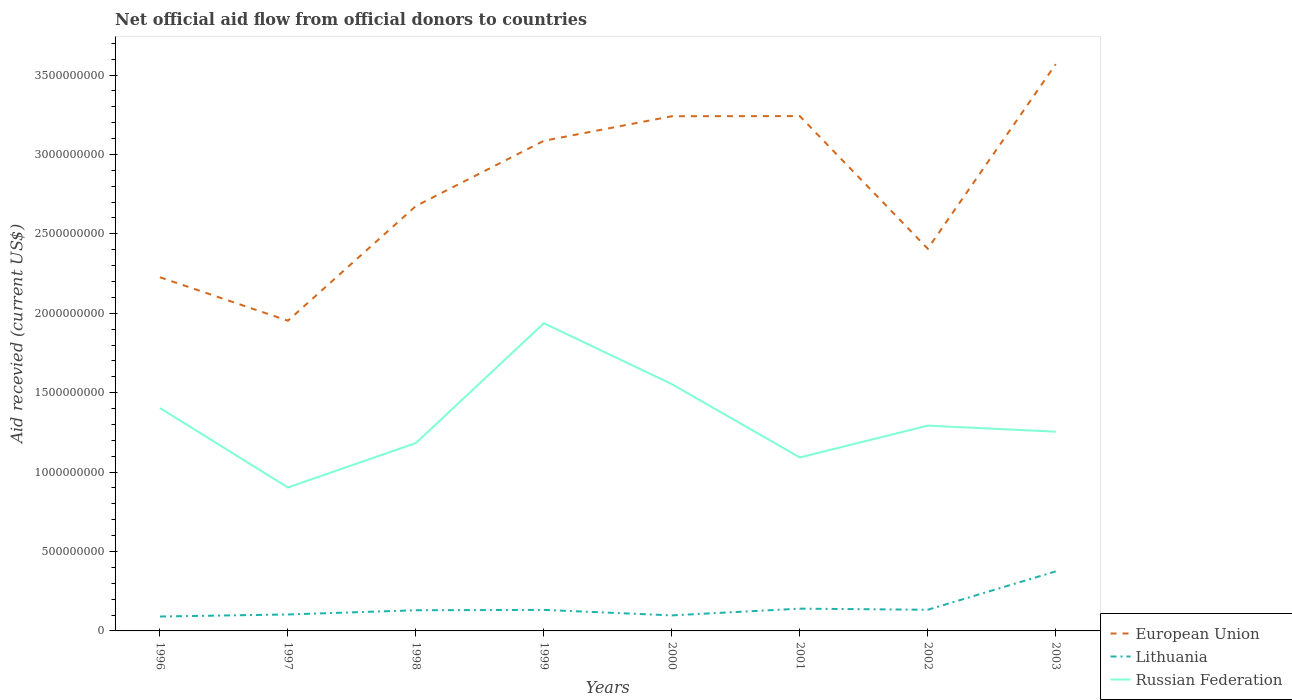How many different coloured lines are there?
Provide a short and direct response. 3. Does the line corresponding to Russian Federation intersect with the line corresponding to Lithuania?
Offer a very short reply. No. Across all years, what is the maximum total aid received in European Union?
Provide a short and direct response. 1.95e+09. In which year was the total aid received in Russian Federation maximum?
Provide a short and direct response. 1997. What is the total total aid received in European Union in the graph?
Make the answer very short. -1.16e+09. What is the difference between the highest and the second highest total aid received in Lithuania?
Provide a short and direct response. 2.84e+08. How many years are there in the graph?
Provide a succinct answer. 8. What is the difference between two consecutive major ticks on the Y-axis?
Make the answer very short. 5.00e+08. Are the values on the major ticks of Y-axis written in scientific E-notation?
Your answer should be compact. No. Does the graph contain any zero values?
Provide a succinct answer. No. Where does the legend appear in the graph?
Provide a short and direct response. Bottom right. How are the legend labels stacked?
Ensure brevity in your answer.  Vertical. What is the title of the graph?
Your response must be concise. Net official aid flow from official donors to countries. What is the label or title of the Y-axis?
Make the answer very short. Aid recevied (current US$). What is the Aid recevied (current US$) of European Union in 1996?
Your response must be concise. 2.23e+09. What is the Aid recevied (current US$) of Lithuania in 1996?
Keep it short and to the point. 9.07e+07. What is the Aid recevied (current US$) of Russian Federation in 1996?
Give a very brief answer. 1.40e+09. What is the Aid recevied (current US$) in European Union in 1997?
Provide a short and direct response. 1.95e+09. What is the Aid recevied (current US$) in Lithuania in 1997?
Your response must be concise. 1.04e+08. What is the Aid recevied (current US$) of Russian Federation in 1997?
Provide a short and direct response. 9.03e+08. What is the Aid recevied (current US$) of European Union in 1998?
Keep it short and to the point. 2.68e+09. What is the Aid recevied (current US$) in Lithuania in 1998?
Ensure brevity in your answer.  1.30e+08. What is the Aid recevied (current US$) in Russian Federation in 1998?
Your answer should be very brief. 1.18e+09. What is the Aid recevied (current US$) in European Union in 1999?
Ensure brevity in your answer.  3.09e+09. What is the Aid recevied (current US$) of Lithuania in 1999?
Your answer should be compact. 1.32e+08. What is the Aid recevied (current US$) of Russian Federation in 1999?
Offer a very short reply. 1.94e+09. What is the Aid recevied (current US$) in European Union in 2000?
Your answer should be very brief. 3.24e+09. What is the Aid recevied (current US$) of Lithuania in 2000?
Offer a terse response. 9.78e+07. What is the Aid recevied (current US$) in Russian Federation in 2000?
Give a very brief answer. 1.55e+09. What is the Aid recevied (current US$) in European Union in 2001?
Provide a short and direct response. 3.24e+09. What is the Aid recevied (current US$) in Lithuania in 2001?
Provide a short and direct response. 1.40e+08. What is the Aid recevied (current US$) of Russian Federation in 2001?
Your response must be concise. 1.09e+09. What is the Aid recevied (current US$) in European Union in 2002?
Make the answer very short. 2.41e+09. What is the Aid recevied (current US$) in Lithuania in 2002?
Give a very brief answer. 1.33e+08. What is the Aid recevied (current US$) in Russian Federation in 2002?
Offer a terse response. 1.29e+09. What is the Aid recevied (current US$) of European Union in 2003?
Provide a succinct answer. 3.57e+09. What is the Aid recevied (current US$) in Lithuania in 2003?
Provide a succinct answer. 3.75e+08. What is the Aid recevied (current US$) in Russian Federation in 2003?
Offer a very short reply. 1.25e+09. Across all years, what is the maximum Aid recevied (current US$) of European Union?
Provide a short and direct response. 3.57e+09. Across all years, what is the maximum Aid recevied (current US$) of Lithuania?
Ensure brevity in your answer.  3.75e+08. Across all years, what is the maximum Aid recevied (current US$) of Russian Federation?
Provide a short and direct response. 1.94e+09. Across all years, what is the minimum Aid recevied (current US$) in European Union?
Your answer should be compact. 1.95e+09. Across all years, what is the minimum Aid recevied (current US$) of Lithuania?
Your response must be concise. 9.07e+07. Across all years, what is the minimum Aid recevied (current US$) in Russian Federation?
Your answer should be very brief. 9.03e+08. What is the total Aid recevied (current US$) in European Union in the graph?
Give a very brief answer. 2.24e+1. What is the total Aid recevied (current US$) of Lithuania in the graph?
Give a very brief answer. 1.20e+09. What is the total Aid recevied (current US$) in Russian Federation in the graph?
Offer a very short reply. 1.06e+1. What is the difference between the Aid recevied (current US$) of European Union in 1996 and that in 1997?
Ensure brevity in your answer.  2.73e+08. What is the difference between the Aid recevied (current US$) of Lithuania in 1996 and that in 1997?
Make the answer very short. -1.29e+07. What is the difference between the Aid recevied (current US$) in Russian Federation in 1996 and that in 1997?
Your response must be concise. 5.00e+08. What is the difference between the Aid recevied (current US$) in European Union in 1996 and that in 1998?
Your answer should be compact. -4.49e+08. What is the difference between the Aid recevied (current US$) in Lithuania in 1996 and that in 1998?
Provide a short and direct response. -3.94e+07. What is the difference between the Aid recevied (current US$) of Russian Federation in 1996 and that in 1998?
Give a very brief answer. 2.20e+08. What is the difference between the Aid recevied (current US$) of European Union in 1996 and that in 1999?
Give a very brief answer. -8.59e+08. What is the difference between the Aid recevied (current US$) of Lithuania in 1996 and that in 1999?
Your answer should be very brief. -4.17e+07. What is the difference between the Aid recevied (current US$) in Russian Federation in 1996 and that in 1999?
Provide a succinct answer. -5.34e+08. What is the difference between the Aid recevied (current US$) in European Union in 1996 and that in 2000?
Offer a very short reply. -1.01e+09. What is the difference between the Aid recevied (current US$) in Lithuania in 1996 and that in 2000?
Offer a terse response. -7.10e+06. What is the difference between the Aid recevied (current US$) of Russian Federation in 1996 and that in 2000?
Give a very brief answer. -1.51e+08. What is the difference between the Aid recevied (current US$) in European Union in 1996 and that in 2001?
Give a very brief answer. -1.01e+09. What is the difference between the Aid recevied (current US$) of Lithuania in 1996 and that in 2001?
Your response must be concise. -4.95e+07. What is the difference between the Aid recevied (current US$) of Russian Federation in 1996 and that in 2001?
Offer a very short reply. 3.11e+08. What is the difference between the Aid recevied (current US$) in European Union in 1996 and that in 2002?
Ensure brevity in your answer.  -1.80e+08. What is the difference between the Aid recevied (current US$) in Lithuania in 1996 and that in 2002?
Your answer should be compact. -4.25e+07. What is the difference between the Aid recevied (current US$) of Russian Federation in 1996 and that in 2002?
Keep it short and to the point. 1.11e+08. What is the difference between the Aid recevied (current US$) of European Union in 1996 and that in 2003?
Provide a succinct answer. -1.34e+09. What is the difference between the Aid recevied (current US$) of Lithuania in 1996 and that in 2003?
Your answer should be very brief. -2.84e+08. What is the difference between the Aid recevied (current US$) in Russian Federation in 1996 and that in 2003?
Your response must be concise. 1.49e+08. What is the difference between the Aid recevied (current US$) of European Union in 1997 and that in 1998?
Give a very brief answer. -7.22e+08. What is the difference between the Aid recevied (current US$) in Lithuania in 1997 and that in 1998?
Ensure brevity in your answer.  -2.66e+07. What is the difference between the Aid recevied (current US$) in Russian Federation in 1997 and that in 1998?
Provide a short and direct response. -2.80e+08. What is the difference between the Aid recevied (current US$) of European Union in 1997 and that in 1999?
Offer a very short reply. -1.13e+09. What is the difference between the Aid recevied (current US$) of Lithuania in 1997 and that in 1999?
Your response must be concise. -2.88e+07. What is the difference between the Aid recevied (current US$) in Russian Federation in 1997 and that in 1999?
Offer a very short reply. -1.03e+09. What is the difference between the Aid recevied (current US$) in European Union in 1997 and that in 2000?
Give a very brief answer. -1.29e+09. What is the difference between the Aid recevied (current US$) of Lithuania in 1997 and that in 2000?
Your answer should be compact. 5.76e+06. What is the difference between the Aid recevied (current US$) in Russian Federation in 1997 and that in 2000?
Give a very brief answer. -6.51e+08. What is the difference between the Aid recevied (current US$) in European Union in 1997 and that in 2001?
Offer a very short reply. -1.29e+09. What is the difference between the Aid recevied (current US$) in Lithuania in 1997 and that in 2001?
Provide a succinct answer. -3.66e+07. What is the difference between the Aid recevied (current US$) of Russian Federation in 1997 and that in 2001?
Ensure brevity in your answer.  -1.89e+08. What is the difference between the Aid recevied (current US$) of European Union in 1997 and that in 2002?
Provide a succinct answer. -4.53e+08. What is the difference between the Aid recevied (current US$) in Lithuania in 1997 and that in 2002?
Make the answer very short. -2.96e+07. What is the difference between the Aid recevied (current US$) in Russian Federation in 1997 and that in 2002?
Ensure brevity in your answer.  -3.89e+08. What is the difference between the Aid recevied (current US$) in European Union in 1997 and that in 2003?
Your answer should be compact. -1.62e+09. What is the difference between the Aid recevied (current US$) in Lithuania in 1997 and that in 2003?
Keep it short and to the point. -2.71e+08. What is the difference between the Aid recevied (current US$) of Russian Federation in 1997 and that in 2003?
Offer a terse response. -3.51e+08. What is the difference between the Aid recevied (current US$) in European Union in 1998 and that in 1999?
Provide a short and direct response. -4.11e+08. What is the difference between the Aid recevied (current US$) in Lithuania in 1998 and that in 1999?
Give a very brief answer. -2.27e+06. What is the difference between the Aid recevied (current US$) in Russian Federation in 1998 and that in 1999?
Your response must be concise. -7.54e+08. What is the difference between the Aid recevied (current US$) of European Union in 1998 and that in 2000?
Give a very brief answer. -5.65e+08. What is the difference between the Aid recevied (current US$) in Lithuania in 1998 and that in 2000?
Keep it short and to the point. 3.23e+07. What is the difference between the Aid recevied (current US$) in Russian Federation in 1998 and that in 2000?
Your response must be concise. -3.71e+08. What is the difference between the Aid recevied (current US$) of European Union in 1998 and that in 2001?
Give a very brief answer. -5.66e+08. What is the difference between the Aid recevied (current US$) of Lithuania in 1998 and that in 2001?
Provide a short and direct response. -1.01e+07. What is the difference between the Aid recevied (current US$) of Russian Federation in 1998 and that in 2001?
Provide a succinct answer. 9.10e+07. What is the difference between the Aid recevied (current US$) in European Union in 1998 and that in 2002?
Give a very brief answer. 2.69e+08. What is the difference between the Aid recevied (current US$) of Lithuania in 1998 and that in 2002?
Provide a short and direct response. -3.08e+06. What is the difference between the Aid recevied (current US$) of Russian Federation in 1998 and that in 2002?
Provide a succinct answer. -1.09e+08. What is the difference between the Aid recevied (current US$) in European Union in 1998 and that in 2003?
Give a very brief answer. -8.93e+08. What is the difference between the Aid recevied (current US$) in Lithuania in 1998 and that in 2003?
Provide a succinct answer. -2.45e+08. What is the difference between the Aid recevied (current US$) of Russian Federation in 1998 and that in 2003?
Keep it short and to the point. -7.13e+07. What is the difference between the Aid recevied (current US$) in European Union in 1999 and that in 2000?
Provide a short and direct response. -1.55e+08. What is the difference between the Aid recevied (current US$) in Lithuania in 1999 and that in 2000?
Keep it short and to the point. 3.46e+07. What is the difference between the Aid recevied (current US$) of Russian Federation in 1999 and that in 2000?
Your answer should be very brief. 3.84e+08. What is the difference between the Aid recevied (current US$) of European Union in 1999 and that in 2001?
Your answer should be compact. -1.55e+08. What is the difference between the Aid recevied (current US$) of Lithuania in 1999 and that in 2001?
Offer a terse response. -7.83e+06. What is the difference between the Aid recevied (current US$) in Russian Federation in 1999 and that in 2001?
Your response must be concise. 8.45e+08. What is the difference between the Aid recevied (current US$) in European Union in 1999 and that in 2002?
Provide a short and direct response. 6.79e+08. What is the difference between the Aid recevied (current US$) of Lithuania in 1999 and that in 2002?
Your response must be concise. -8.10e+05. What is the difference between the Aid recevied (current US$) of Russian Federation in 1999 and that in 2002?
Keep it short and to the point. 6.45e+08. What is the difference between the Aid recevied (current US$) in European Union in 1999 and that in 2003?
Provide a succinct answer. -4.82e+08. What is the difference between the Aid recevied (current US$) in Lithuania in 1999 and that in 2003?
Your answer should be very brief. -2.42e+08. What is the difference between the Aid recevied (current US$) in Russian Federation in 1999 and that in 2003?
Ensure brevity in your answer.  6.83e+08. What is the difference between the Aid recevied (current US$) of European Union in 2000 and that in 2001?
Offer a very short reply. -7.70e+05. What is the difference between the Aid recevied (current US$) in Lithuania in 2000 and that in 2001?
Provide a short and direct response. -4.24e+07. What is the difference between the Aid recevied (current US$) of Russian Federation in 2000 and that in 2001?
Give a very brief answer. 4.62e+08. What is the difference between the Aid recevied (current US$) in European Union in 2000 and that in 2002?
Ensure brevity in your answer.  8.34e+08. What is the difference between the Aid recevied (current US$) in Lithuania in 2000 and that in 2002?
Your response must be concise. -3.54e+07. What is the difference between the Aid recevied (current US$) in Russian Federation in 2000 and that in 2002?
Give a very brief answer. 2.61e+08. What is the difference between the Aid recevied (current US$) in European Union in 2000 and that in 2003?
Ensure brevity in your answer.  -3.28e+08. What is the difference between the Aid recevied (current US$) in Lithuania in 2000 and that in 2003?
Your answer should be very brief. -2.77e+08. What is the difference between the Aid recevied (current US$) in Russian Federation in 2000 and that in 2003?
Your answer should be compact. 2.99e+08. What is the difference between the Aid recevied (current US$) of European Union in 2001 and that in 2002?
Your response must be concise. 8.35e+08. What is the difference between the Aid recevied (current US$) of Lithuania in 2001 and that in 2002?
Keep it short and to the point. 7.02e+06. What is the difference between the Aid recevied (current US$) in Russian Federation in 2001 and that in 2002?
Provide a short and direct response. -2.00e+08. What is the difference between the Aid recevied (current US$) in European Union in 2001 and that in 2003?
Your answer should be compact. -3.27e+08. What is the difference between the Aid recevied (current US$) of Lithuania in 2001 and that in 2003?
Make the answer very short. -2.34e+08. What is the difference between the Aid recevied (current US$) of Russian Federation in 2001 and that in 2003?
Give a very brief answer. -1.62e+08. What is the difference between the Aid recevied (current US$) of European Union in 2002 and that in 2003?
Make the answer very short. -1.16e+09. What is the difference between the Aid recevied (current US$) in Lithuania in 2002 and that in 2003?
Your answer should be compact. -2.41e+08. What is the difference between the Aid recevied (current US$) of Russian Federation in 2002 and that in 2003?
Make the answer very short. 3.80e+07. What is the difference between the Aid recevied (current US$) in European Union in 1996 and the Aid recevied (current US$) in Lithuania in 1997?
Your answer should be compact. 2.12e+09. What is the difference between the Aid recevied (current US$) in European Union in 1996 and the Aid recevied (current US$) in Russian Federation in 1997?
Ensure brevity in your answer.  1.32e+09. What is the difference between the Aid recevied (current US$) of Lithuania in 1996 and the Aid recevied (current US$) of Russian Federation in 1997?
Your answer should be very brief. -8.12e+08. What is the difference between the Aid recevied (current US$) of European Union in 1996 and the Aid recevied (current US$) of Lithuania in 1998?
Provide a succinct answer. 2.10e+09. What is the difference between the Aid recevied (current US$) of European Union in 1996 and the Aid recevied (current US$) of Russian Federation in 1998?
Make the answer very short. 1.04e+09. What is the difference between the Aid recevied (current US$) in Lithuania in 1996 and the Aid recevied (current US$) in Russian Federation in 1998?
Give a very brief answer. -1.09e+09. What is the difference between the Aid recevied (current US$) of European Union in 1996 and the Aid recevied (current US$) of Lithuania in 1999?
Your response must be concise. 2.09e+09. What is the difference between the Aid recevied (current US$) of European Union in 1996 and the Aid recevied (current US$) of Russian Federation in 1999?
Keep it short and to the point. 2.89e+08. What is the difference between the Aid recevied (current US$) in Lithuania in 1996 and the Aid recevied (current US$) in Russian Federation in 1999?
Offer a very short reply. -1.85e+09. What is the difference between the Aid recevied (current US$) in European Union in 1996 and the Aid recevied (current US$) in Lithuania in 2000?
Offer a terse response. 2.13e+09. What is the difference between the Aid recevied (current US$) of European Union in 1996 and the Aid recevied (current US$) of Russian Federation in 2000?
Make the answer very short. 6.73e+08. What is the difference between the Aid recevied (current US$) of Lithuania in 1996 and the Aid recevied (current US$) of Russian Federation in 2000?
Keep it short and to the point. -1.46e+09. What is the difference between the Aid recevied (current US$) of European Union in 1996 and the Aid recevied (current US$) of Lithuania in 2001?
Your answer should be compact. 2.09e+09. What is the difference between the Aid recevied (current US$) in European Union in 1996 and the Aid recevied (current US$) in Russian Federation in 2001?
Make the answer very short. 1.13e+09. What is the difference between the Aid recevied (current US$) of Lithuania in 1996 and the Aid recevied (current US$) of Russian Federation in 2001?
Make the answer very short. -1.00e+09. What is the difference between the Aid recevied (current US$) of European Union in 1996 and the Aid recevied (current US$) of Lithuania in 2002?
Ensure brevity in your answer.  2.09e+09. What is the difference between the Aid recevied (current US$) of European Union in 1996 and the Aid recevied (current US$) of Russian Federation in 2002?
Make the answer very short. 9.34e+08. What is the difference between the Aid recevied (current US$) of Lithuania in 1996 and the Aid recevied (current US$) of Russian Federation in 2002?
Provide a short and direct response. -1.20e+09. What is the difference between the Aid recevied (current US$) of European Union in 1996 and the Aid recevied (current US$) of Lithuania in 2003?
Offer a very short reply. 1.85e+09. What is the difference between the Aid recevied (current US$) in European Union in 1996 and the Aid recevied (current US$) in Russian Federation in 2003?
Give a very brief answer. 9.72e+08. What is the difference between the Aid recevied (current US$) of Lithuania in 1996 and the Aid recevied (current US$) of Russian Federation in 2003?
Ensure brevity in your answer.  -1.16e+09. What is the difference between the Aid recevied (current US$) of European Union in 1997 and the Aid recevied (current US$) of Lithuania in 1998?
Your response must be concise. 1.82e+09. What is the difference between the Aid recevied (current US$) in European Union in 1997 and the Aid recevied (current US$) in Russian Federation in 1998?
Give a very brief answer. 7.70e+08. What is the difference between the Aid recevied (current US$) in Lithuania in 1997 and the Aid recevied (current US$) in Russian Federation in 1998?
Ensure brevity in your answer.  -1.08e+09. What is the difference between the Aid recevied (current US$) in European Union in 1997 and the Aid recevied (current US$) in Lithuania in 1999?
Offer a terse response. 1.82e+09. What is the difference between the Aid recevied (current US$) in European Union in 1997 and the Aid recevied (current US$) in Russian Federation in 1999?
Provide a short and direct response. 1.57e+07. What is the difference between the Aid recevied (current US$) of Lithuania in 1997 and the Aid recevied (current US$) of Russian Federation in 1999?
Provide a short and direct response. -1.83e+09. What is the difference between the Aid recevied (current US$) in European Union in 1997 and the Aid recevied (current US$) in Lithuania in 2000?
Ensure brevity in your answer.  1.86e+09. What is the difference between the Aid recevied (current US$) of European Union in 1997 and the Aid recevied (current US$) of Russian Federation in 2000?
Keep it short and to the point. 3.99e+08. What is the difference between the Aid recevied (current US$) of Lithuania in 1997 and the Aid recevied (current US$) of Russian Federation in 2000?
Provide a short and direct response. -1.45e+09. What is the difference between the Aid recevied (current US$) in European Union in 1997 and the Aid recevied (current US$) in Lithuania in 2001?
Your answer should be compact. 1.81e+09. What is the difference between the Aid recevied (current US$) in European Union in 1997 and the Aid recevied (current US$) in Russian Federation in 2001?
Ensure brevity in your answer.  8.61e+08. What is the difference between the Aid recevied (current US$) in Lithuania in 1997 and the Aid recevied (current US$) in Russian Federation in 2001?
Ensure brevity in your answer.  -9.89e+08. What is the difference between the Aid recevied (current US$) of European Union in 1997 and the Aid recevied (current US$) of Lithuania in 2002?
Offer a very short reply. 1.82e+09. What is the difference between the Aid recevied (current US$) in European Union in 1997 and the Aid recevied (current US$) in Russian Federation in 2002?
Offer a very short reply. 6.61e+08. What is the difference between the Aid recevied (current US$) of Lithuania in 1997 and the Aid recevied (current US$) of Russian Federation in 2002?
Provide a succinct answer. -1.19e+09. What is the difference between the Aid recevied (current US$) of European Union in 1997 and the Aid recevied (current US$) of Lithuania in 2003?
Provide a succinct answer. 1.58e+09. What is the difference between the Aid recevied (current US$) in European Union in 1997 and the Aid recevied (current US$) in Russian Federation in 2003?
Make the answer very short. 6.99e+08. What is the difference between the Aid recevied (current US$) in Lithuania in 1997 and the Aid recevied (current US$) in Russian Federation in 2003?
Offer a very short reply. -1.15e+09. What is the difference between the Aid recevied (current US$) in European Union in 1998 and the Aid recevied (current US$) in Lithuania in 1999?
Provide a short and direct response. 2.54e+09. What is the difference between the Aid recevied (current US$) of European Union in 1998 and the Aid recevied (current US$) of Russian Federation in 1999?
Offer a terse response. 7.38e+08. What is the difference between the Aid recevied (current US$) in Lithuania in 1998 and the Aid recevied (current US$) in Russian Federation in 1999?
Your response must be concise. -1.81e+09. What is the difference between the Aid recevied (current US$) in European Union in 1998 and the Aid recevied (current US$) in Lithuania in 2000?
Provide a succinct answer. 2.58e+09. What is the difference between the Aid recevied (current US$) of European Union in 1998 and the Aid recevied (current US$) of Russian Federation in 2000?
Your response must be concise. 1.12e+09. What is the difference between the Aid recevied (current US$) of Lithuania in 1998 and the Aid recevied (current US$) of Russian Federation in 2000?
Provide a short and direct response. -1.42e+09. What is the difference between the Aid recevied (current US$) in European Union in 1998 and the Aid recevied (current US$) in Lithuania in 2001?
Your answer should be compact. 2.53e+09. What is the difference between the Aid recevied (current US$) in European Union in 1998 and the Aid recevied (current US$) in Russian Federation in 2001?
Offer a terse response. 1.58e+09. What is the difference between the Aid recevied (current US$) of Lithuania in 1998 and the Aid recevied (current US$) of Russian Federation in 2001?
Give a very brief answer. -9.62e+08. What is the difference between the Aid recevied (current US$) in European Union in 1998 and the Aid recevied (current US$) in Lithuania in 2002?
Offer a very short reply. 2.54e+09. What is the difference between the Aid recevied (current US$) of European Union in 1998 and the Aid recevied (current US$) of Russian Federation in 2002?
Give a very brief answer. 1.38e+09. What is the difference between the Aid recevied (current US$) of Lithuania in 1998 and the Aid recevied (current US$) of Russian Federation in 2002?
Offer a terse response. -1.16e+09. What is the difference between the Aid recevied (current US$) of European Union in 1998 and the Aid recevied (current US$) of Lithuania in 2003?
Ensure brevity in your answer.  2.30e+09. What is the difference between the Aid recevied (current US$) in European Union in 1998 and the Aid recevied (current US$) in Russian Federation in 2003?
Your answer should be very brief. 1.42e+09. What is the difference between the Aid recevied (current US$) of Lithuania in 1998 and the Aid recevied (current US$) of Russian Federation in 2003?
Ensure brevity in your answer.  -1.12e+09. What is the difference between the Aid recevied (current US$) in European Union in 1999 and the Aid recevied (current US$) in Lithuania in 2000?
Provide a succinct answer. 2.99e+09. What is the difference between the Aid recevied (current US$) in European Union in 1999 and the Aid recevied (current US$) in Russian Federation in 2000?
Provide a succinct answer. 1.53e+09. What is the difference between the Aid recevied (current US$) of Lithuania in 1999 and the Aid recevied (current US$) of Russian Federation in 2000?
Ensure brevity in your answer.  -1.42e+09. What is the difference between the Aid recevied (current US$) in European Union in 1999 and the Aid recevied (current US$) in Lithuania in 2001?
Ensure brevity in your answer.  2.95e+09. What is the difference between the Aid recevied (current US$) in European Union in 1999 and the Aid recevied (current US$) in Russian Federation in 2001?
Ensure brevity in your answer.  1.99e+09. What is the difference between the Aid recevied (current US$) of Lithuania in 1999 and the Aid recevied (current US$) of Russian Federation in 2001?
Your response must be concise. -9.60e+08. What is the difference between the Aid recevied (current US$) in European Union in 1999 and the Aid recevied (current US$) in Lithuania in 2002?
Give a very brief answer. 2.95e+09. What is the difference between the Aid recevied (current US$) in European Union in 1999 and the Aid recevied (current US$) in Russian Federation in 2002?
Make the answer very short. 1.79e+09. What is the difference between the Aid recevied (current US$) in Lithuania in 1999 and the Aid recevied (current US$) in Russian Federation in 2002?
Your answer should be very brief. -1.16e+09. What is the difference between the Aid recevied (current US$) in European Union in 1999 and the Aid recevied (current US$) in Lithuania in 2003?
Make the answer very short. 2.71e+09. What is the difference between the Aid recevied (current US$) of European Union in 1999 and the Aid recevied (current US$) of Russian Federation in 2003?
Your answer should be very brief. 1.83e+09. What is the difference between the Aid recevied (current US$) in Lithuania in 1999 and the Aid recevied (current US$) in Russian Federation in 2003?
Provide a short and direct response. -1.12e+09. What is the difference between the Aid recevied (current US$) in European Union in 2000 and the Aid recevied (current US$) in Lithuania in 2001?
Ensure brevity in your answer.  3.10e+09. What is the difference between the Aid recevied (current US$) in European Union in 2000 and the Aid recevied (current US$) in Russian Federation in 2001?
Provide a succinct answer. 2.15e+09. What is the difference between the Aid recevied (current US$) in Lithuania in 2000 and the Aid recevied (current US$) in Russian Federation in 2001?
Ensure brevity in your answer.  -9.94e+08. What is the difference between the Aid recevied (current US$) in European Union in 2000 and the Aid recevied (current US$) in Lithuania in 2002?
Your response must be concise. 3.11e+09. What is the difference between the Aid recevied (current US$) in European Union in 2000 and the Aid recevied (current US$) in Russian Federation in 2002?
Your answer should be very brief. 1.95e+09. What is the difference between the Aid recevied (current US$) of Lithuania in 2000 and the Aid recevied (current US$) of Russian Federation in 2002?
Your answer should be very brief. -1.19e+09. What is the difference between the Aid recevied (current US$) in European Union in 2000 and the Aid recevied (current US$) in Lithuania in 2003?
Ensure brevity in your answer.  2.87e+09. What is the difference between the Aid recevied (current US$) of European Union in 2000 and the Aid recevied (current US$) of Russian Federation in 2003?
Your answer should be compact. 1.99e+09. What is the difference between the Aid recevied (current US$) of Lithuania in 2000 and the Aid recevied (current US$) of Russian Federation in 2003?
Offer a terse response. -1.16e+09. What is the difference between the Aid recevied (current US$) of European Union in 2001 and the Aid recevied (current US$) of Lithuania in 2002?
Your answer should be very brief. 3.11e+09. What is the difference between the Aid recevied (current US$) of European Union in 2001 and the Aid recevied (current US$) of Russian Federation in 2002?
Offer a terse response. 1.95e+09. What is the difference between the Aid recevied (current US$) in Lithuania in 2001 and the Aid recevied (current US$) in Russian Federation in 2002?
Your response must be concise. -1.15e+09. What is the difference between the Aid recevied (current US$) in European Union in 2001 and the Aid recevied (current US$) in Lithuania in 2003?
Keep it short and to the point. 2.87e+09. What is the difference between the Aid recevied (current US$) of European Union in 2001 and the Aid recevied (current US$) of Russian Federation in 2003?
Give a very brief answer. 1.99e+09. What is the difference between the Aid recevied (current US$) in Lithuania in 2001 and the Aid recevied (current US$) in Russian Federation in 2003?
Offer a very short reply. -1.11e+09. What is the difference between the Aid recevied (current US$) in European Union in 2002 and the Aid recevied (current US$) in Lithuania in 2003?
Provide a short and direct response. 2.03e+09. What is the difference between the Aid recevied (current US$) of European Union in 2002 and the Aid recevied (current US$) of Russian Federation in 2003?
Your answer should be very brief. 1.15e+09. What is the difference between the Aid recevied (current US$) in Lithuania in 2002 and the Aid recevied (current US$) in Russian Federation in 2003?
Provide a succinct answer. -1.12e+09. What is the average Aid recevied (current US$) of European Union per year?
Offer a very short reply. 2.80e+09. What is the average Aid recevied (current US$) in Lithuania per year?
Keep it short and to the point. 1.50e+08. What is the average Aid recevied (current US$) in Russian Federation per year?
Your answer should be very brief. 1.33e+09. In the year 1996, what is the difference between the Aid recevied (current US$) in European Union and Aid recevied (current US$) in Lithuania?
Offer a terse response. 2.14e+09. In the year 1996, what is the difference between the Aid recevied (current US$) of European Union and Aid recevied (current US$) of Russian Federation?
Provide a succinct answer. 8.23e+08. In the year 1996, what is the difference between the Aid recevied (current US$) in Lithuania and Aid recevied (current US$) in Russian Federation?
Your response must be concise. -1.31e+09. In the year 1997, what is the difference between the Aid recevied (current US$) of European Union and Aid recevied (current US$) of Lithuania?
Your answer should be very brief. 1.85e+09. In the year 1997, what is the difference between the Aid recevied (current US$) of European Union and Aid recevied (current US$) of Russian Federation?
Your answer should be compact. 1.05e+09. In the year 1997, what is the difference between the Aid recevied (current US$) in Lithuania and Aid recevied (current US$) in Russian Federation?
Your response must be concise. -7.99e+08. In the year 1998, what is the difference between the Aid recevied (current US$) of European Union and Aid recevied (current US$) of Lithuania?
Make the answer very short. 2.55e+09. In the year 1998, what is the difference between the Aid recevied (current US$) of European Union and Aid recevied (current US$) of Russian Federation?
Provide a short and direct response. 1.49e+09. In the year 1998, what is the difference between the Aid recevied (current US$) of Lithuania and Aid recevied (current US$) of Russian Federation?
Give a very brief answer. -1.05e+09. In the year 1999, what is the difference between the Aid recevied (current US$) of European Union and Aid recevied (current US$) of Lithuania?
Your response must be concise. 2.95e+09. In the year 1999, what is the difference between the Aid recevied (current US$) of European Union and Aid recevied (current US$) of Russian Federation?
Offer a terse response. 1.15e+09. In the year 1999, what is the difference between the Aid recevied (current US$) in Lithuania and Aid recevied (current US$) in Russian Federation?
Your answer should be very brief. -1.80e+09. In the year 2000, what is the difference between the Aid recevied (current US$) of European Union and Aid recevied (current US$) of Lithuania?
Your answer should be very brief. 3.14e+09. In the year 2000, what is the difference between the Aid recevied (current US$) of European Union and Aid recevied (current US$) of Russian Federation?
Provide a succinct answer. 1.69e+09. In the year 2000, what is the difference between the Aid recevied (current US$) of Lithuania and Aid recevied (current US$) of Russian Federation?
Make the answer very short. -1.46e+09. In the year 2001, what is the difference between the Aid recevied (current US$) in European Union and Aid recevied (current US$) in Lithuania?
Provide a short and direct response. 3.10e+09. In the year 2001, what is the difference between the Aid recevied (current US$) in European Union and Aid recevied (current US$) in Russian Federation?
Keep it short and to the point. 2.15e+09. In the year 2001, what is the difference between the Aid recevied (current US$) in Lithuania and Aid recevied (current US$) in Russian Federation?
Provide a short and direct response. -9.52e+08. In the year 2002, what is the difference between the Aid recevied (current US$) in European Union and Aid recevied (current US$) in Lithuania?
Your answer should be very brief. 2.27e+09. In the year 2002, what is the difference between the Aid recevied (current US$) in European Union and Aid recevied (current US$) in Russian Federation?
Your answer should be very brief. 1.11e+09. In the year 2002, what is the difference between the Aid recevied (current US$) of Lithuania and Aid recevied (current US$) of Russian Federation?
Make the answer very short. -1.16e+09. In the year 2003, what is the difference between the Aid recevied (current US$) in European Union and Aid recevied (current US$) in Lithuania?
Give a very brief answer. 3.19e+09. In the year 2003, what is the difference between the Aid recevied (current US$) of European Union and Aid recevied (current US$) of Russian Federation?
Provide a short and direct response. 2.31e+09. In the year 2003, what is the difference between the Aid recevied (current US$) in Lithuania and Aid recevied (current US$) in Russian Federation?
Your answer should be very brief. -8.80e+08. What is the ratio of the Aid recevied (current US$) in European Union in 1996 to that in 1997?
Provide a short and direct response. 1.14. What is the ratio of the Aid recevied (current US$) in Lithuania in 1996 to that in 1997?
Your answer should be very brief. 0.88. What is the ratio of the Aid recevied (current US$) of Russian Federation in 1996 to that in 1997?
Your answer should be compact. 1.55. What is the ratio of the Aid recevied (current US$) of European Union in 1996 to that in 1998?
Provide a short and direct response. 0.83. What is the ratio of the Aid recevied (current US$) in Lithuania in 1996 to that in 1998?
Make the answer very short. 0.7. What is the ratio of the Aid recevied (current US$) in Russian Federation in 1996 to that in 1998?
Give a very brief answer. 1.19. What is the ratio of the Aid recevied (current US$) in European Union in 1996 to that in 1999?
Provide a short and direct response. 0.72. What is the ratio of the Aid recevied (current US$) in Lithuania in 1996 to that in 1999?
Keep it short and to the point. 0.69. What is the ratio of the Aid recevied (current US$) of Russian Federation in 1996 to that in 1999?
Give a very brief answer. 0.72. What is the ratio of the Aid recevied (current US$) of European Union in 1996 to that in 2000?
Give a very brief answer. 0.69. What is the ratio of the Aid recevied (current US$) in Lithuania in 1996 to that in 2000?
Keep it short and to the point. 0.93. What is the ratio of the Aid recevied (current US$) in Russian Federation in 1996 to that in 2000?
Keep it short and to the point. 0.9. What is the ratio of the Aid recevied (current US$) in European Union in 1996 to that in 2001?
Make the answer very short. 0.69. What is the ratio of the Aid recevied (current US$) of Lithuania in 1996 to that in 2001?
Offer a terse response. 0.65. What is the ratio of the Aid recevied (current US$) in Russian Federation in 1996 to that in 2001?
Ensure brevity in your answer.  1.28. What is the ratio of the Aid recevied (current US$) in European Union in 1996 to that in 2002?
Offer a very short reply. 0.93. What is the ratio of the Aid recevied (current US$) in Lithuania in 1996 to that in 2002?
Your answer should be compact. 0.68. What is the ratio of the Aid recevied (current US$) in Russian Federation in 1996 to that in 2002?
Provide a short and direct response. 1.09. What is the ratio of the Aid recevied (current US$) of European Union in 1996 to that in 2003?
Make the answer very short. 0.62. What is the ratio of the Aid recevied (current US$) of Lithuania in 1996 to that in 2003?
Offer a terse response. 0.24. What is the ratio of the Aid recevied (current US$) in Russian Federation in 1996 to that in 2003?
Give a very brief answer. 1.12. What is the ratio of the Aid recevied (current US$) in European Union in 1997 to that in 1998?
Your answer should be compact. 0.73. What is the ratio of the Aid recevied (current US$) of Lithuania in 1997 to that in 1998?
Make the answer very short. 0.8. What is the ratio of the Aid recevied (current US$) of Russian Federation in 1997 to that in 1998?
Your answer should be very brief. 0.76. What is the ratio of the Aid recevied (current US$) in European Union in 1997 to that in 1999?
Make the answer very short. 0.63. What is the ratio of the Aid recevied (current US$) of Lithuania in 1997 to that in 1999?
Give a very brief answer. 0.78. What is the ratio of the Aid recevied (current US$) of Russian Federation in 1997 to that in 1999?
Give a very brief answer. 0.47. What is the ratio of the Aid recevied (current US$) of European Union in 1997 to that in 2000?
Your answer should be very brief. 0.6. What is the ratio of the Aid recevied (current US$) of Lithuania in 1997 to that in 2000?
Offer a very short reply. 1.06. What is the ratio of the Aid recevied (current US$) of Russian Federation in 1997 to that in 2000?
Make the answer very short. 0.58. What is the ratio of the Aid recevied (current US$) of European Union in 1997 to that in 2001?
Ensure brevity in your answer.  0.6. What is the ratio of the Aid recevied (current US$) of Lithuania in 1997 to that in 2001?
Keep it short and to the point. 0.74. What is the ratio of the Aid recevied (current US$) of Russian Federation in 1997 to that in 2001?
Give a very brief answer. 0.83. What is the ratio of the Aid recevied (current US$) in European Union in 1997 to that in 2002?
Your answer should be compact. 0.81. What is the ratio of the Aid recevied (current US$) of Lithuania in 1997 to that in 2002?
Offer a terse response. 0.78. What is the ratio of the Aid recevied (current US$) of Russian Federation in 1997 to that in 2002?
Offer a terse response. 0.7. What is the ratio of the Aid recevied (current US$) in European Union in 1997 to that in 2003?
Give a very brief answer. 0.55. What is the ratio of the Aid recevied (current US$) in Lithuania in 1997 to that in 2003?
Your answer should be compact. 0.28. What is the ratio of the Aid recevied (current US$) of Russian Federation in 1997 to that in 2003?
Your answer should be compact. 0.72. What is the ratio of the Aid recevied (current US$) in European Union in 1998 to that in 1999?
Keep it short and to the point. 0.87. What is the ratio of the Aid recevied (current US$) in Lithuania in 1998 to that in 1999?
Your answer should be compact. 0.98. What is the ratio of the Aid recevied (current US$) in Russian Federation in 1998 to that in 1999?
Your response must be concise. 0.61. What is the ratio of the Aid recevied (current US$) of European Union in 1998 to that in 2000?
Your answer should be very brief. 0.83. What is the ratio of the Aid recevied (current US$) in Lithuania in 1998 to that in 2000?
Your answer should be very brief. 1.33. What is the ratio of the Aid recevied (current US$) in Russian Federation in 1998 to that in 2000?
Give a very brief answer. 0.76. What is the ratio of the Aid recevied (current US$) of European Union in 1998 to that in 2001?
Make the answer very short. 0.83. What is the ratio of the Aid recevied (current US$) in Lithuania in 1998 to that in 2001?
Offer a very short reply. 0.93. What is the ratio of the Aid recevied (current US$) in European Union in 1998 to that in 2002?
Your answer should be very brief. 1.11. What is the ratio of the Aid recevied (current US$) of Lithuania in 1998 to that in 2002?
Provide a succinct answer. 0.98. What is the ratio of the Aid recevied (current US$) of Russian Federation in 1998 to that in 2002?
Provide a succinct answer. 0.92. What is the ratio of the Aid recevied (current US$) in European Union in 1998 to that in 2003?
Make the answer very short. 0.75. What is the ratio of the Aid recevied (current US$) of Lithuania in 1998 to that in 2003?
Give a very brief answer. 0.35. What is the ratio of the Aid recevied (current US$) of Russian Federation in 1998 to that in 2003?
Your response must be concise. 0.94. What is the ratio of the Aid recevied (current US$) of European Union in 1999 to that in 2000?
Your answer should be very brief. 0.95. What is the ratio of the Aid recevied (current US$) in Lithuania in 1999 to that in 2000?
Offer a very short reply. 1.35. What is the ratio of the Aid recevied (current US$) of Russian Federation in 1999 to that in 2000?
Make the answer very short. 1.25. What is the ratio of the Aid recevied (current US$) in European Union in 1999 to that in 2001?
Offer a very short reply. 0.95. What is the ratio of the Aid recevied (current US$) in Lithuania in 1999 to that in 2001?
Give a very brief answer. 0.94. What is the ratio of the Aid recevied (current US$) in Russian Federation in 1999 to that in 2001?
Provide a short and direct response. 1.77. What is the ratio of the Aid recevied (current US$) in European Union in 1999 to that in 2002?
Offer a terse response. 1.28. What is the ratio of the Aid recevied (current US$) in Russian Federation in 1999 to that in 2002?
Your answer should be compact. 1.5. What is the ratio of the Aid recevied (current US$) of European Union in 1999 to that in 2003?
Keep it short and to the point. 0.86. What is the ratio of the Aid recevied (current US$) of Lithuania in 1999 to that in 2003?
Offer a very short reply. 0.35. What is the ratio of the Aid recevied (current US$) of Russian Federation in 1999 to that in 2003?
Offer a very short reply. 1.54. What is the ratio of the Aid recevied (current US$) in European Union in 2000 to that in 2001?
Ensure brevity in your answer.  1. What is the ratio of the Aid recevied (current US$) of Lithuania in 2000 to that in 2001?
Provide a short and direct response. 0.7. What is the ratio of the Aid recevied (current US$) in Russian Federation in 2000 to that in 2001?
Your answer should be very brief. 1.42. What is the ratio of the Aid recevied (current US$) of European Union in 2000 to that in 2002?
Your answer should be compact. 1.35. What is the ratio of the Aid recevied (current US$) in Lithuania in 2000 to that in 2002?
Give a very brief answer. 0.73. What is the ratio of the Aid recevied (current US$) in Russian Federation in 2000 to that in 2002?
Ensure brevity in your answer.  1.2. What is the ratio of the Aid recevied (current US$) of European Union in 2000 to that in 2003?
Ensure brevity in your answer.  0.91. What is the ratio of the Aid recevied (current US$) of Lithuania in 2000 to that in 2003?
Make the answer very short. 0.26. What is the ratio of the Aid recevied (current US$) in Russian Federation in 2000 to that in 2003?
Keep it short and to the point. 1.24. What is the ratio of the Aid recevied (current US$) of European Union in 2001 to that in 2002?
Provide a short and direct response. 1.35. What is the ratio of the Aid recevied (current US$) of Lithuania in 2001 to that in 2002?
Offer a very short reply. 1.05. What is the ratio of the Aid recevied (current US$) in Russian Federation in 2001 to that in 2002?
Your answer should be very brief. 0.84. What is the ratio of the Aid recevied (current US$) of European Union in 2001 to that in 2003?
Make the answer very short. 0.91. What is the ratio of the Aid recevied (current US$) in Lithuania in 2001 to that in 2003?
Provide a short and direct response. 0.37. What is the ratio of the Aid recevied (current US$) in Russian Federation in 2001 to that in 2003?
Give a very brief answer. 0.87. What is the ratio of the Aid recevied (current US$) of European Union in 2002 to that in 2003?
Give a very brief answer. 0.67. What is the ratio of the Aid recevied (current US$) of Lithuania in 2002 to that in 2003?
Make the answer very short. 0.36. What is the ratio of the Aid recevied (current US$) of Russian Federation in 2002 to that in 2003?
Provide a succinct answer. 1.03. What is the difference between the highest and the second highest Aid recevied (current US$) of European Union?
Your answer should be very brief. 3.27e+08. What is the difference between the highest and the second highest Aid recevied (current US$) of Lithuania?
Keep it short and to the point. 2.34e+08. What is the difference between the highest and the second highest Aid recevied (current US$) of Russian Federation?
Your answer should be compact. 3.84e+08. What is the difference between the highest and the lowest Aid recevied (current US$) of European Union?
Offer a terse response. 1.62e+09. What is the difference between the highest and the lowest Aid recevied (current US$) of Lithuania?
Give a very brief answer. 2.84e+08. What is the difference between the highest and the lowest Aid recevied (current US$) in Russian Federation?
Offer a terse response. 1.03e+09. 